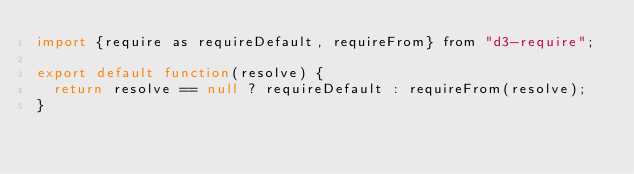<code> <loc_0><loc_0><loc_500><loc_500><_JavaScript_>import {require as requireDefault, requireFrom} from "d3-require";

export default function(resolve) {
  return resolve == null ? requireDefault : requireFrom(resolve);
}
</code> 